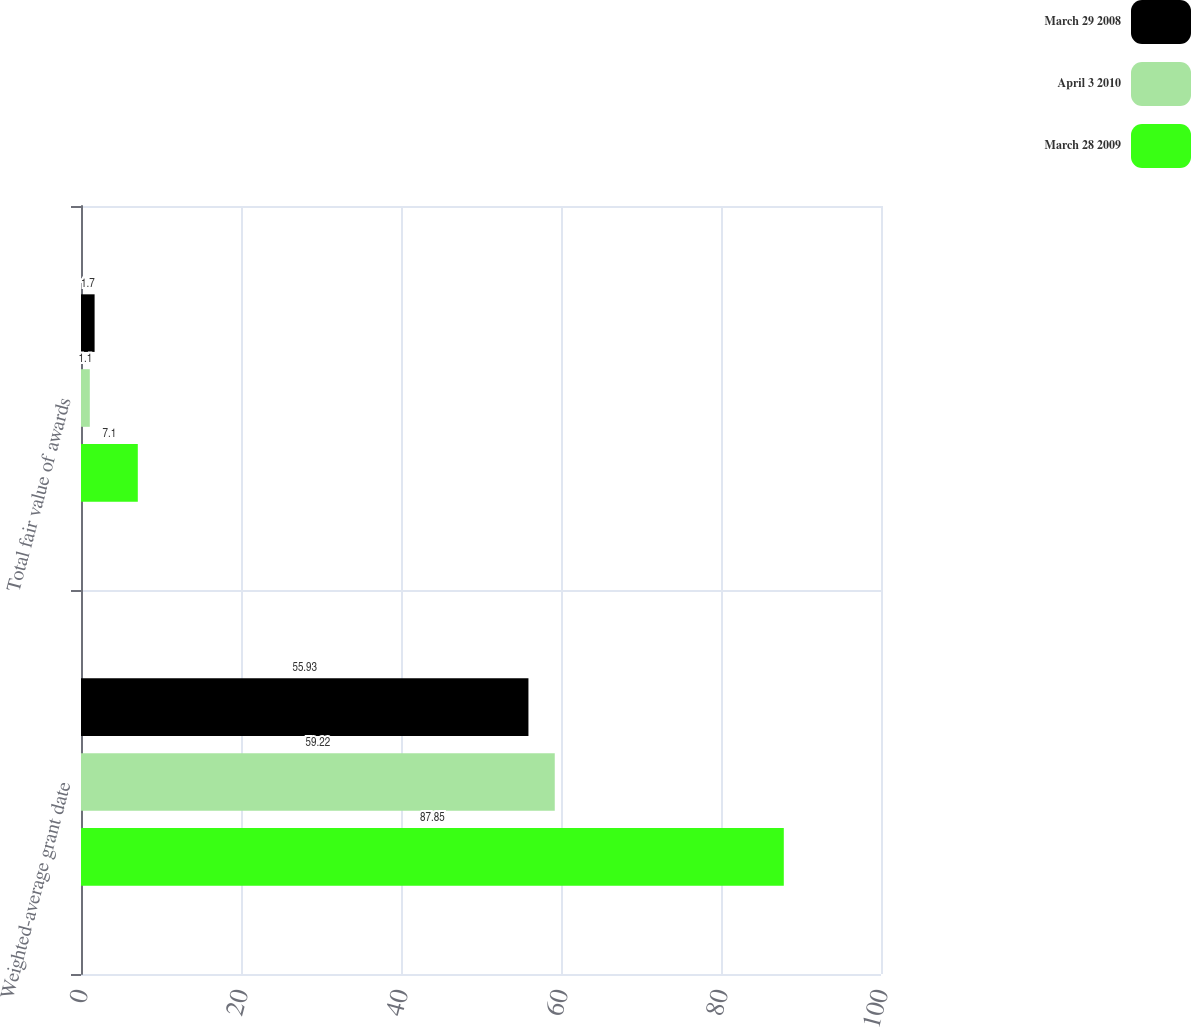Convert chart. <chart><loc_0><loc_0><loc_500><loc_500><stacked_bar_chart><ecel><fcel>Weighted-average grant date<fcel>Total fair value of awards<nl><fcel>March 29 2008<fcel>55.93<fcel>1.7<nl><fcel>April 3 2010<fcel>59.22<fcel>1.1<nl><fcel>March 28 2009<fcel>87.85<fcel>7.1<nl></chart> 